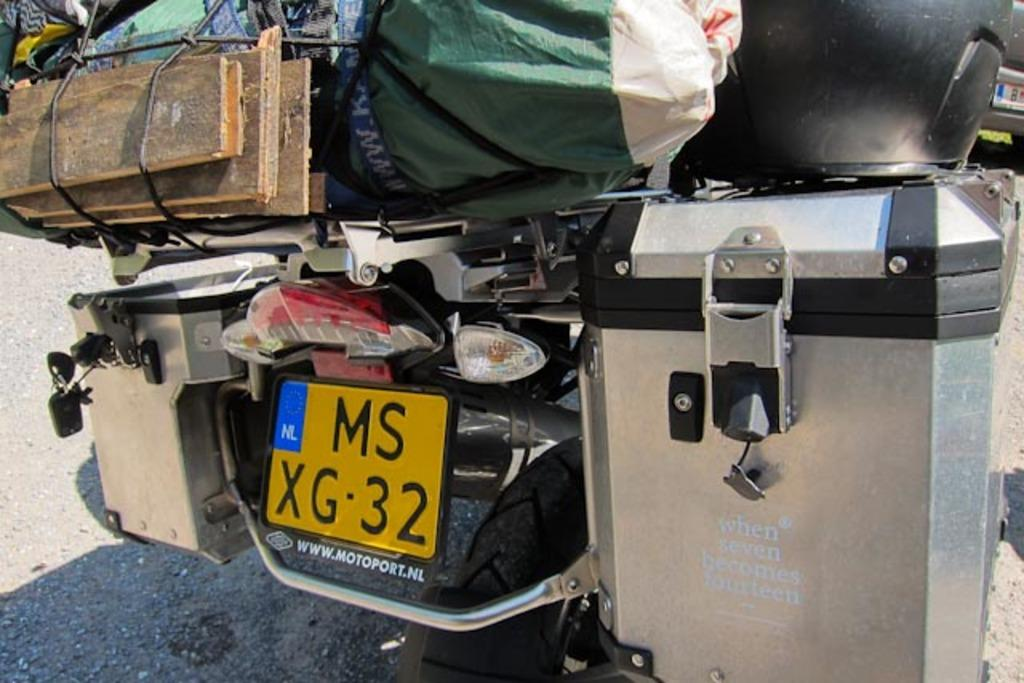What is the main subject of the picture? The main subject of the picture is a vehicle. What type of objects can be seen on the vehicle? There are wooden objects and other objects on the vehicle. What type of amusement can be seen on the vehicle in the image? There is no amusement present on the vehicle in the image. Is the cook preparing a meal on the vehicle in the image? There is no cook or any indication of food preparation on the vehicle in the image. 